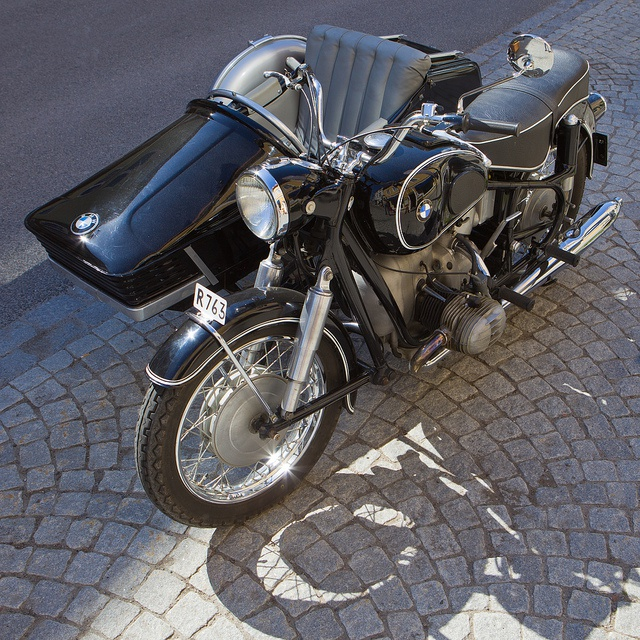Describe the objects in this image and their specific colors. I can see a motorcycle in gray, black, and darkgray tones in this image. 